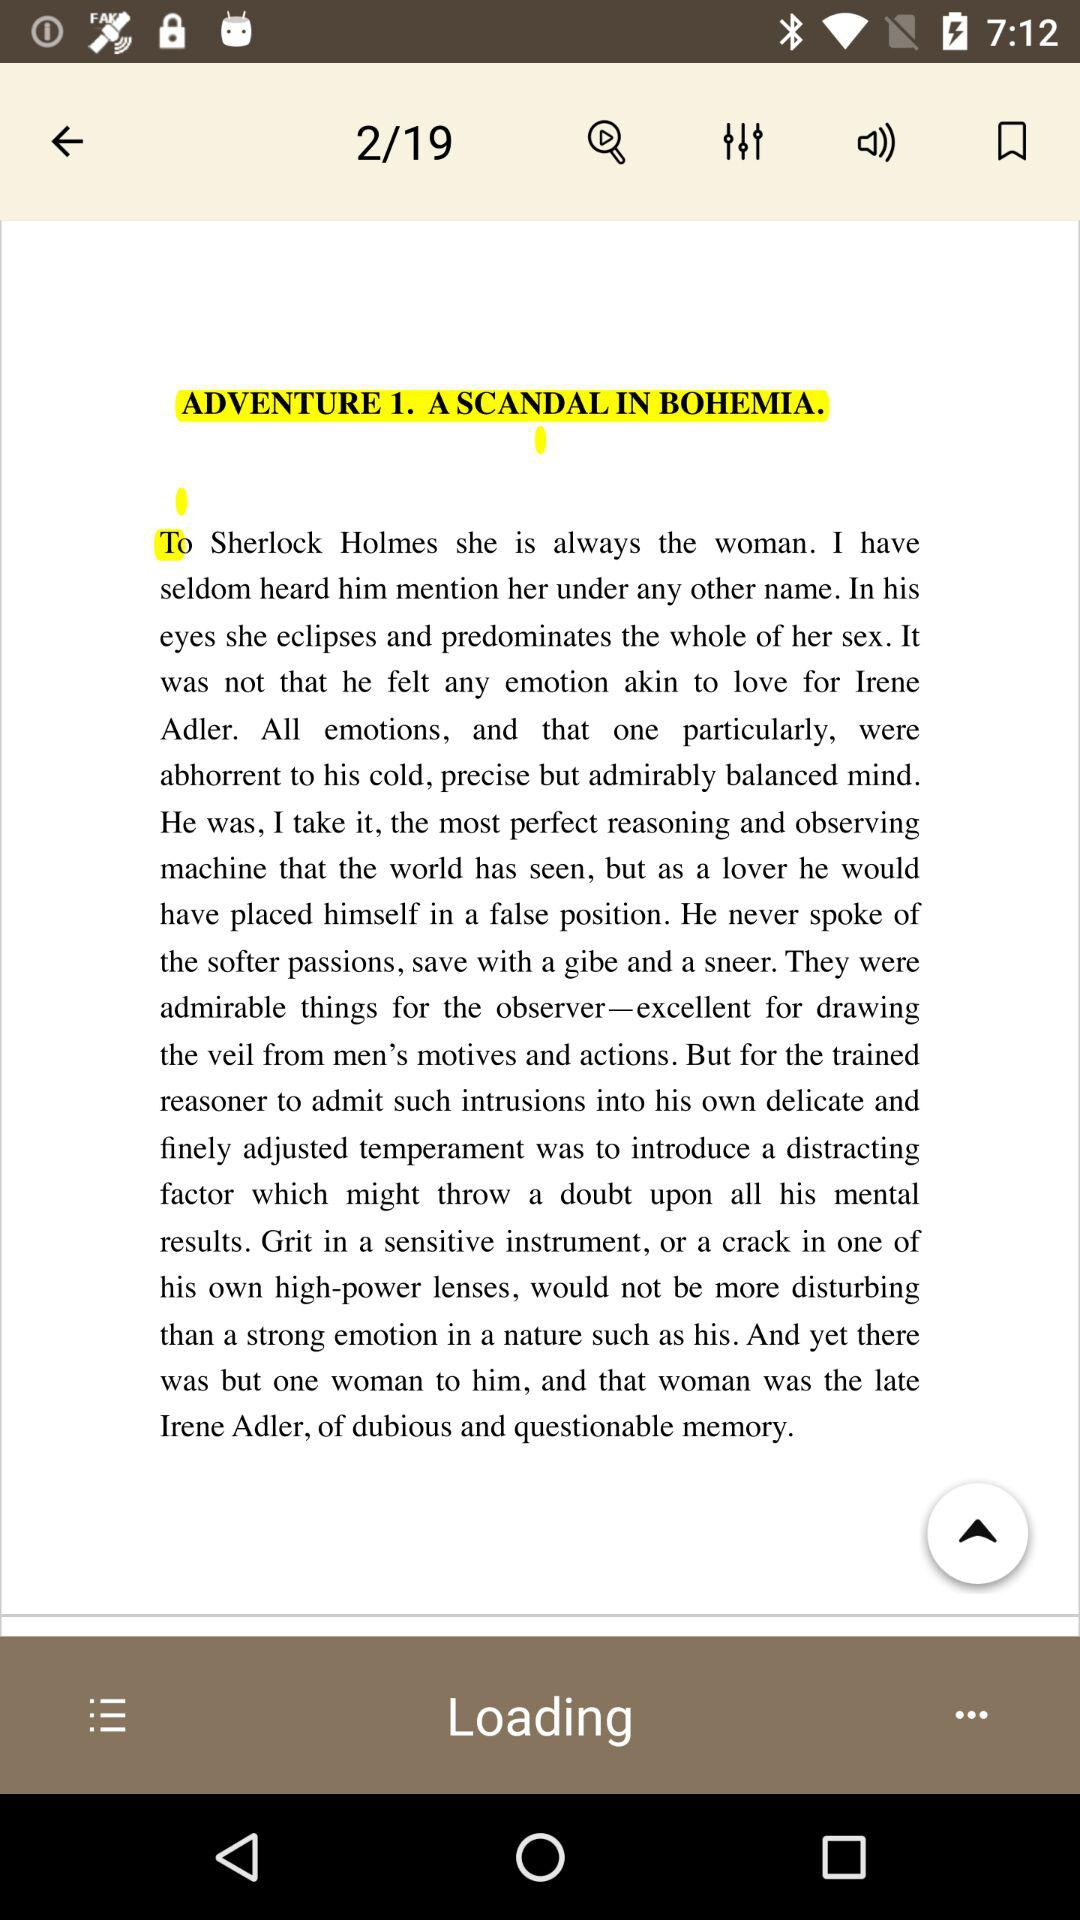What is the total number of pages? The total number of pages is 19. 